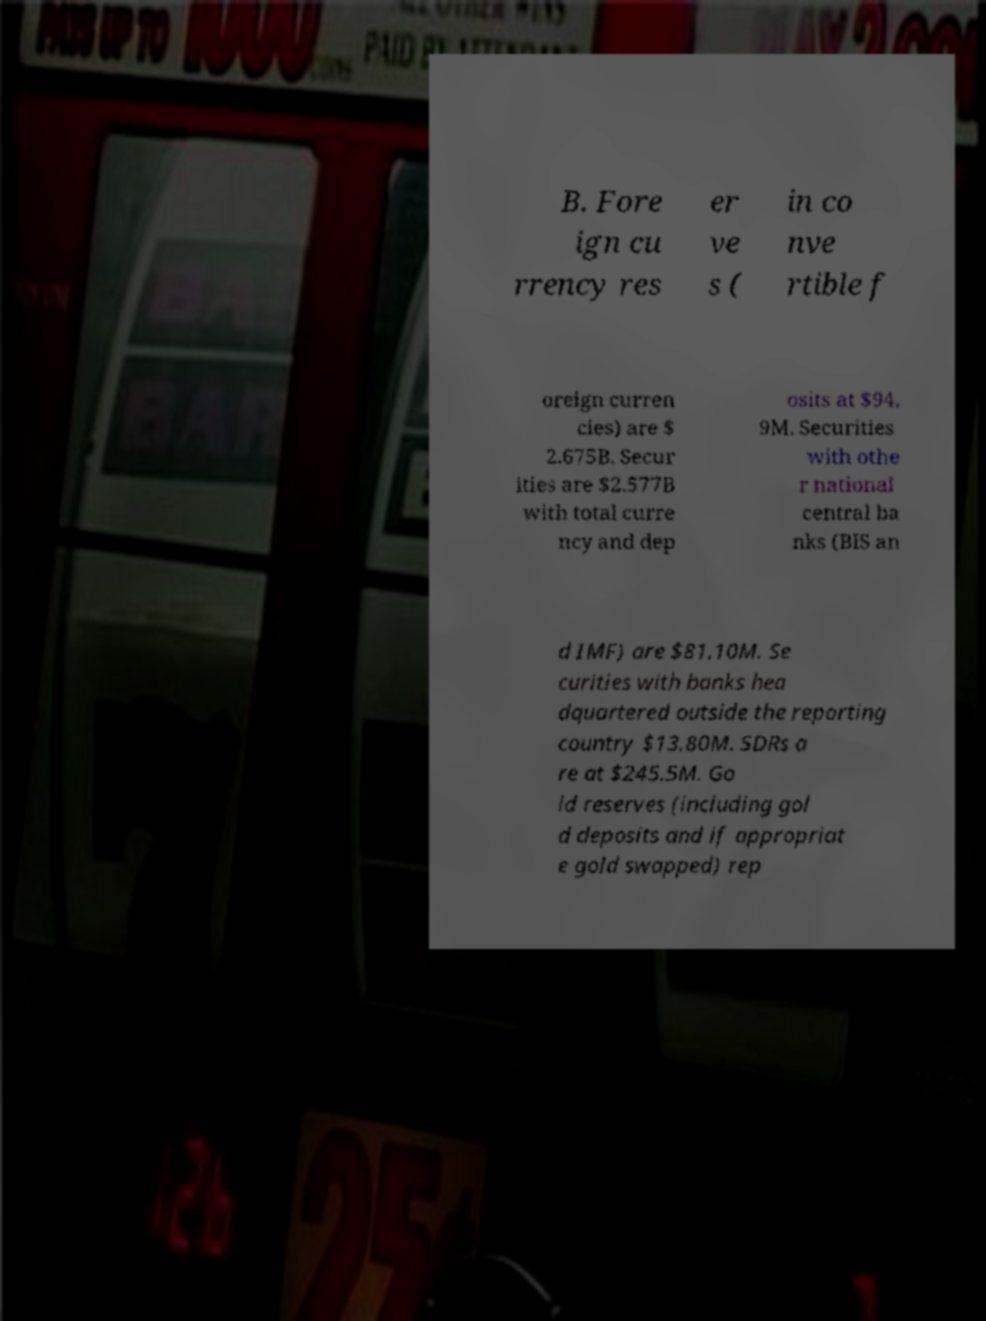Could you assist in decoding the text presented in this image and type it out clearly? B. Fore ign cu rrency res er ve s ( in co nve rtible f oreign curren cies) are $ 2.675B. Secur ities are $2.577B with total curre ncy and dep osits at $94. 9M. Securities with othe r national central ba nks (BIS an d IMF) are $81.10M. Se curities with banks hea dquartered outside the reporting country $13.80M. SDRs a re at $245.5M. Go ld reserves (including gol d deposits and if appropriat e gold swapped) rep 